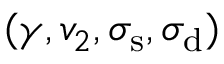Convert formula to latex. <formula><loc_0><loc_0><loc_500><loc_500>( \gamma , v _ { 2 } , \sigma _ { s } , \sigma _ { d } )</formula> 